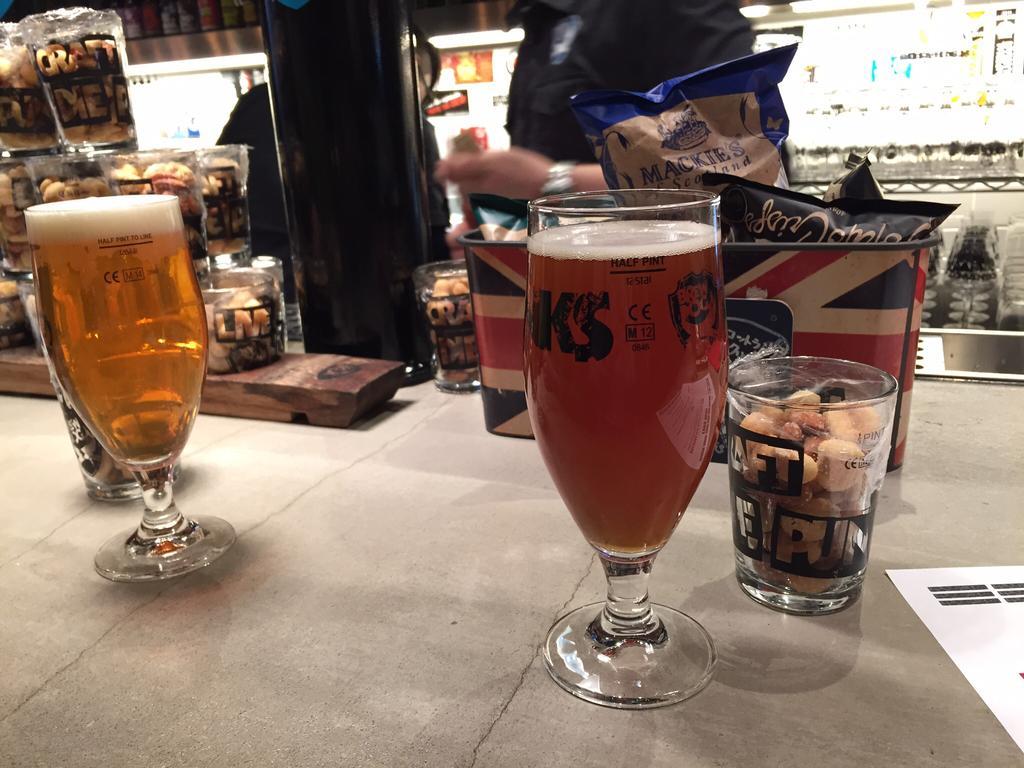How would you summarize this image in a sentence or two? In this image I can see few glasses. In the glass I can see some liquid and I can also see few other persons standing, background I can see few lights and I can see few objects on the table. 